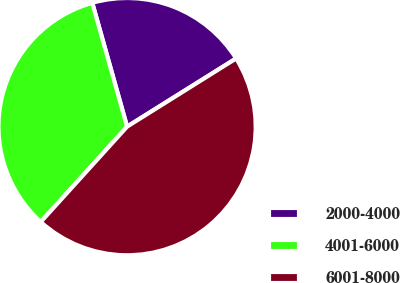Convert chart. <chart><loc_0><loc_0><loc_500><loc_500><pie_chart><fcel>2000-4000<fcel>4001-6000<fcel>6001-8000<nl><fcel>20.47%<fcel>33.92%<fcel>45.61%<nl></chart> 